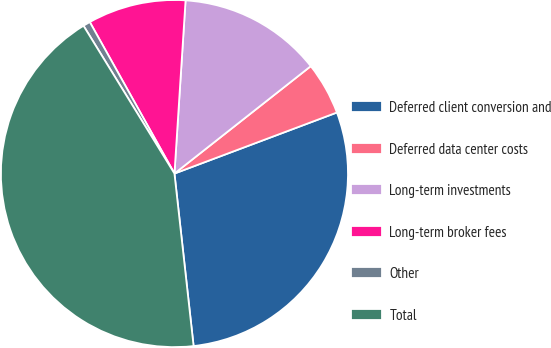Convert chart to OTSL. <chart><loc_0><loc_0><loc_500><loc_500><pie_chart><fcel>Deferred client conversion and<fcel>Deferred data center costs<fcel>Long-term investments<fcel>Long-term broker fees<fcel>Other<fcel>Total<nl><fcel>28.96%<fcel>4.9%<fcel>13.36%<fcel>9.13%<fcel>0.67%<fcel>42.98%<nl></chart> 